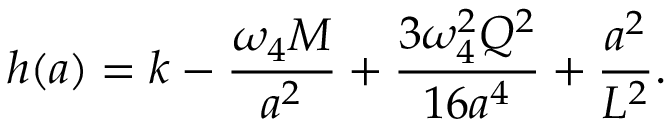<formula> <loc_0><loc_0><loc_500><loc_500>h ( a ) = k - { \frac { \omega _ { 4 } M } { a ^ { 2 } } } + { \frac { 3 \omega _ { 4 } ^ { 2 } Q ^ { 2 } } { 1 6 a ^ { 4 } } } + { \frac { a ^ { 2 } } { L ^ { 2 } } } .</formula> 